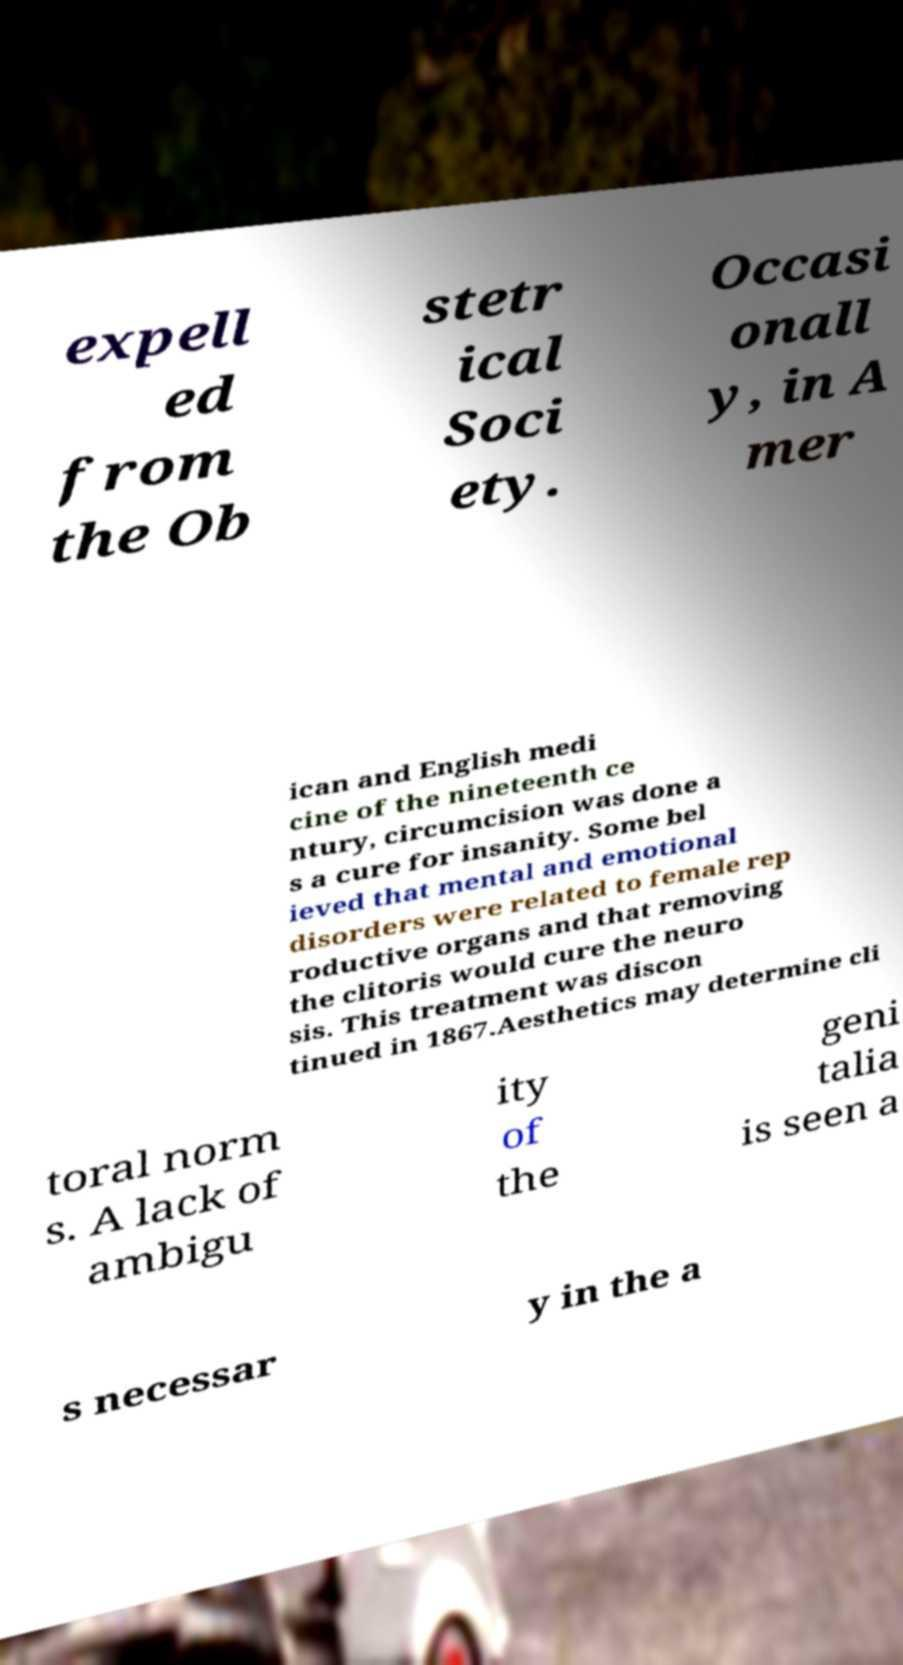There's text embedded in this image that I need extracted. Can you transcribe it verbatim? expell ed from the Ob stetr ical Soci ety. Occasi onall y, in A mer ican and English medi cine of the nineteenth ce ntury, circumcision was done a s a cure for insanity. Some bel ieved that mental and emotional disorders were related to female rep roductive organs and that removing the clitoris would cure the neuro sis. This treatment was discon tinued in 1867.Aesthetics may determine cli toral norm s. A lack of ambigu ity of the geni talia is seen a s necessar y in the a 